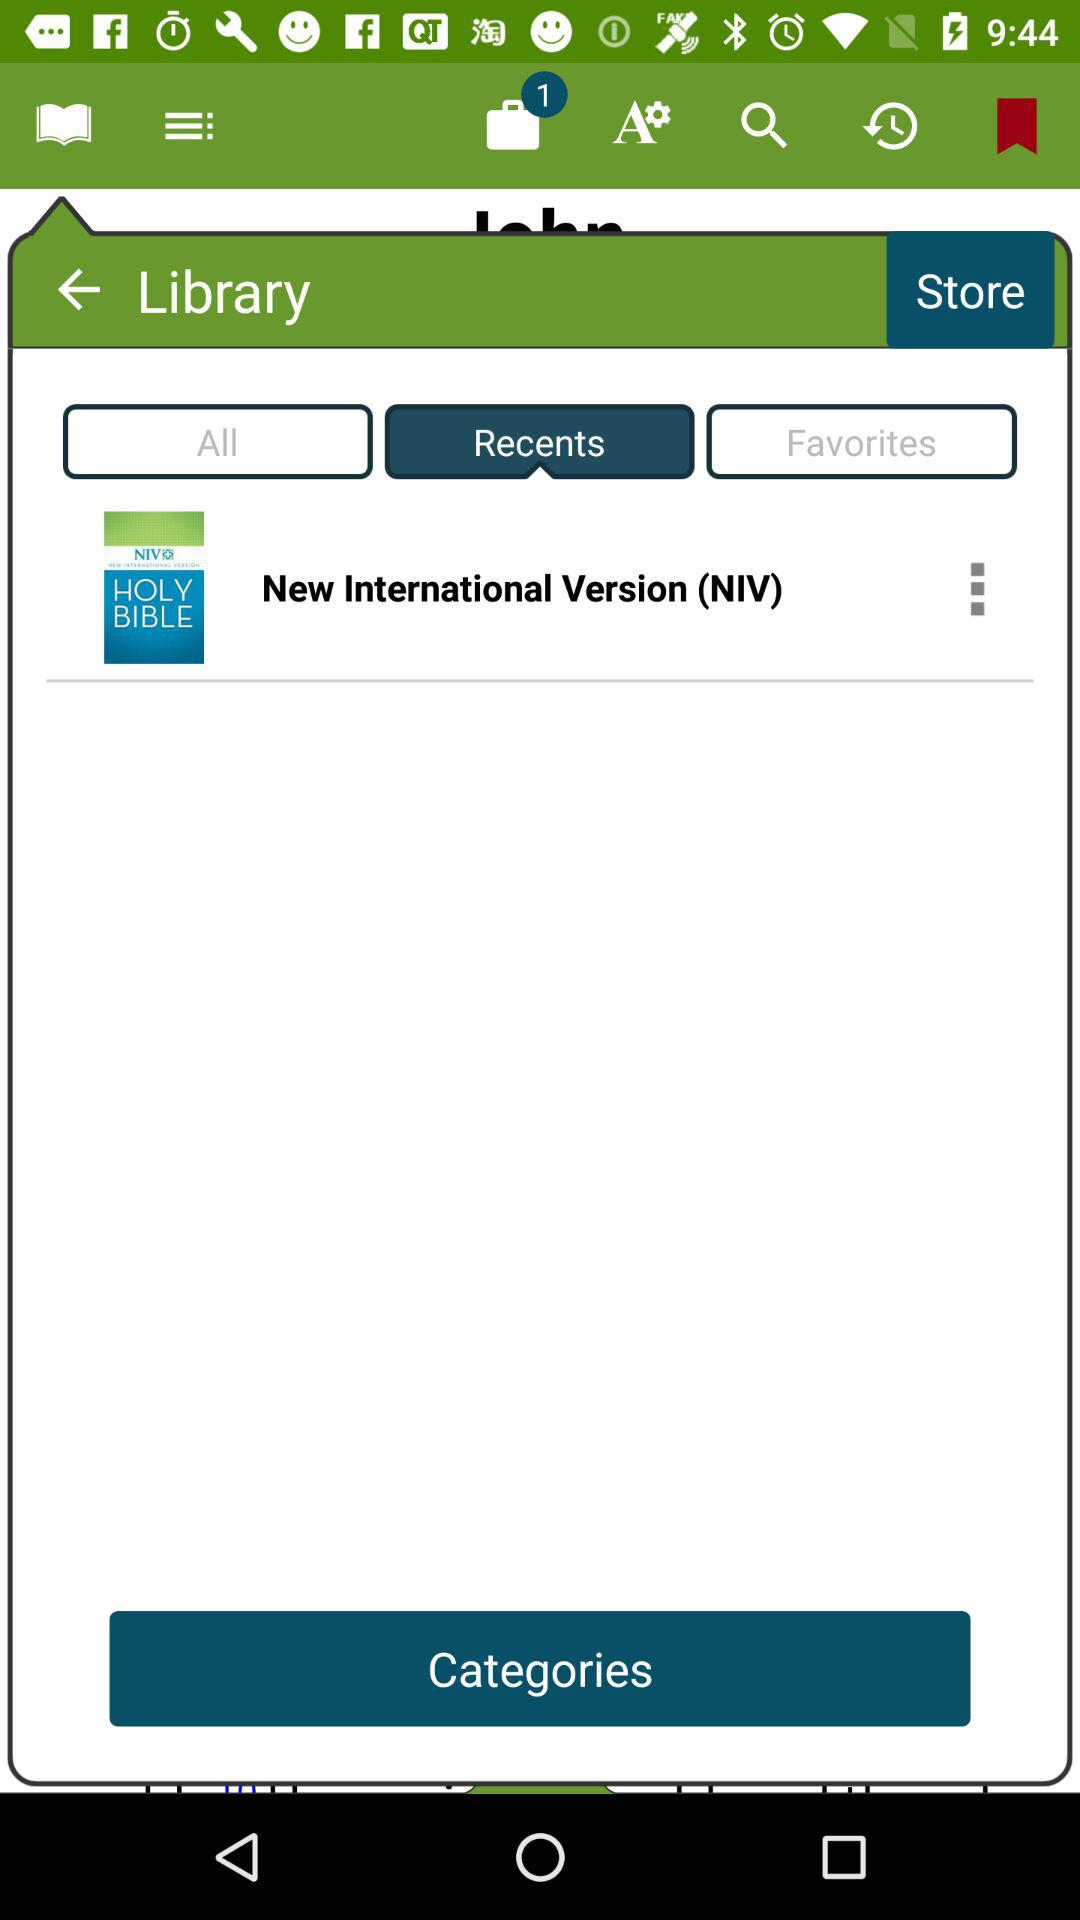How many unread notifications are there? There is 1 unread notification. 